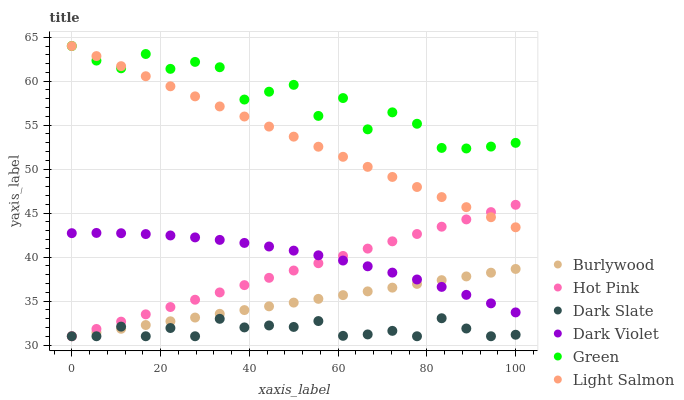Does Dark Slate have the minimum area under the curve?
Answer yes or no. Yes. Does Green have the maximum area under the curve?
Answer yes or no. Yes. Does Burlywood have the minimum area under the curve?
Answer yes or no. No. Does Burlywood have the maximum area under the curve?
Answer yes or no. No. Is Hot Pink the smoothest?
Answer yes or no. Yes. Is Green the roughest?
Answer yes or no. Yes. Is Burlywood the smoothest?
Answer yes or no. No. Is Burlywood the roughest?
Answer yes or no. No. Does Burlywood have the lowest value?
Answer yes or no. Yes. Does Dark Violet have the lowest value?
Answer yes or no. No. Does Green have the highest value?
Answer yes or no. Yes. Does Burlywood have the highest value?
Answer yes or no. No. Is Burlywood less than Green?
Answer yes or no. Yes. Is Light Salmon greater than Dark Slate?
Answer yes or no. Yes. Does Dark Slate intersect Hot Pink?
Answer yes or no. Yes. Is Dark Slate less than Hot Pink?
Answer yes or no. No. Is Dark Slate greater than Hot Pink?
Answer yes or no. No. Does Burlywood intersect Green?
Answer yes or no. No. 